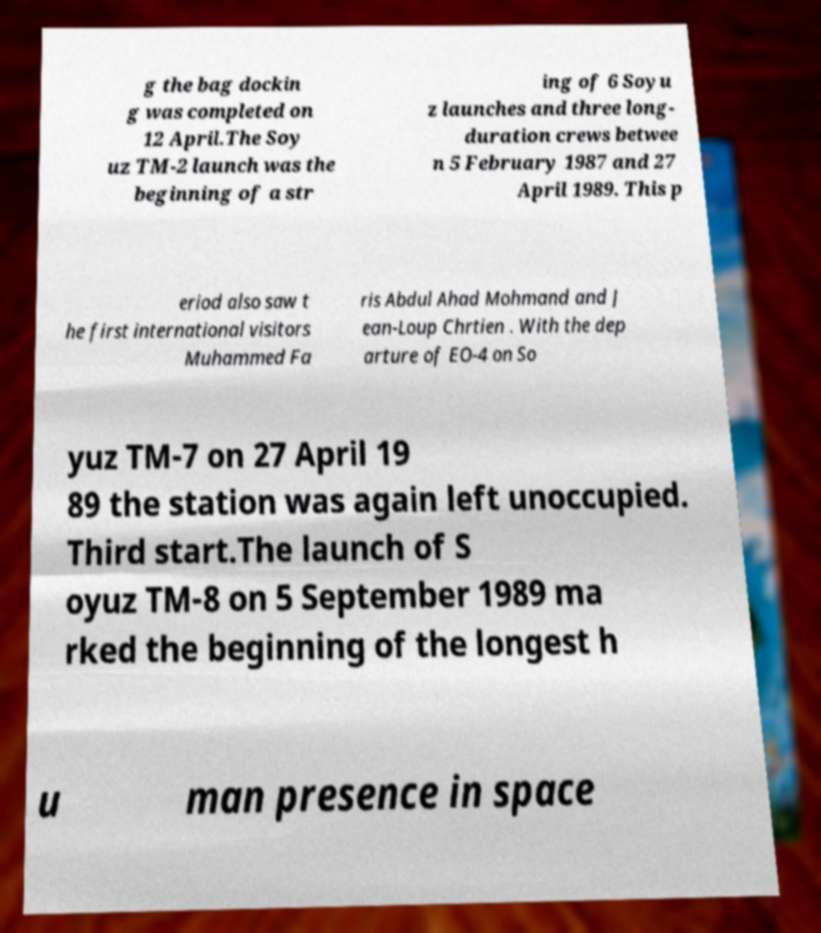Can you read and provide the text displayed in the image?This photo seems to have some interesting text. Can you extract and type it out for me? g the bag dockin g was completed on 12 April.The Soy uz TM-2 launch was the beginning of a str ing of 6 Soyu z launches and three long- duration crews betwee n 5 February 1987 and 27 April 1989. This p eriod also saw t he first international visitors Muhammed Fa ris Abdul Ahad Mohmand and J ean-Loup Chrtien . With the dep arture of EO-4 on So yuz TM-7 on 27 April 19 89 the station was again left unoccupied. Third start.The launch of S oyuz TM-8 on 5 September 1989 ma rked the beginning of the longest h u man presence in space 